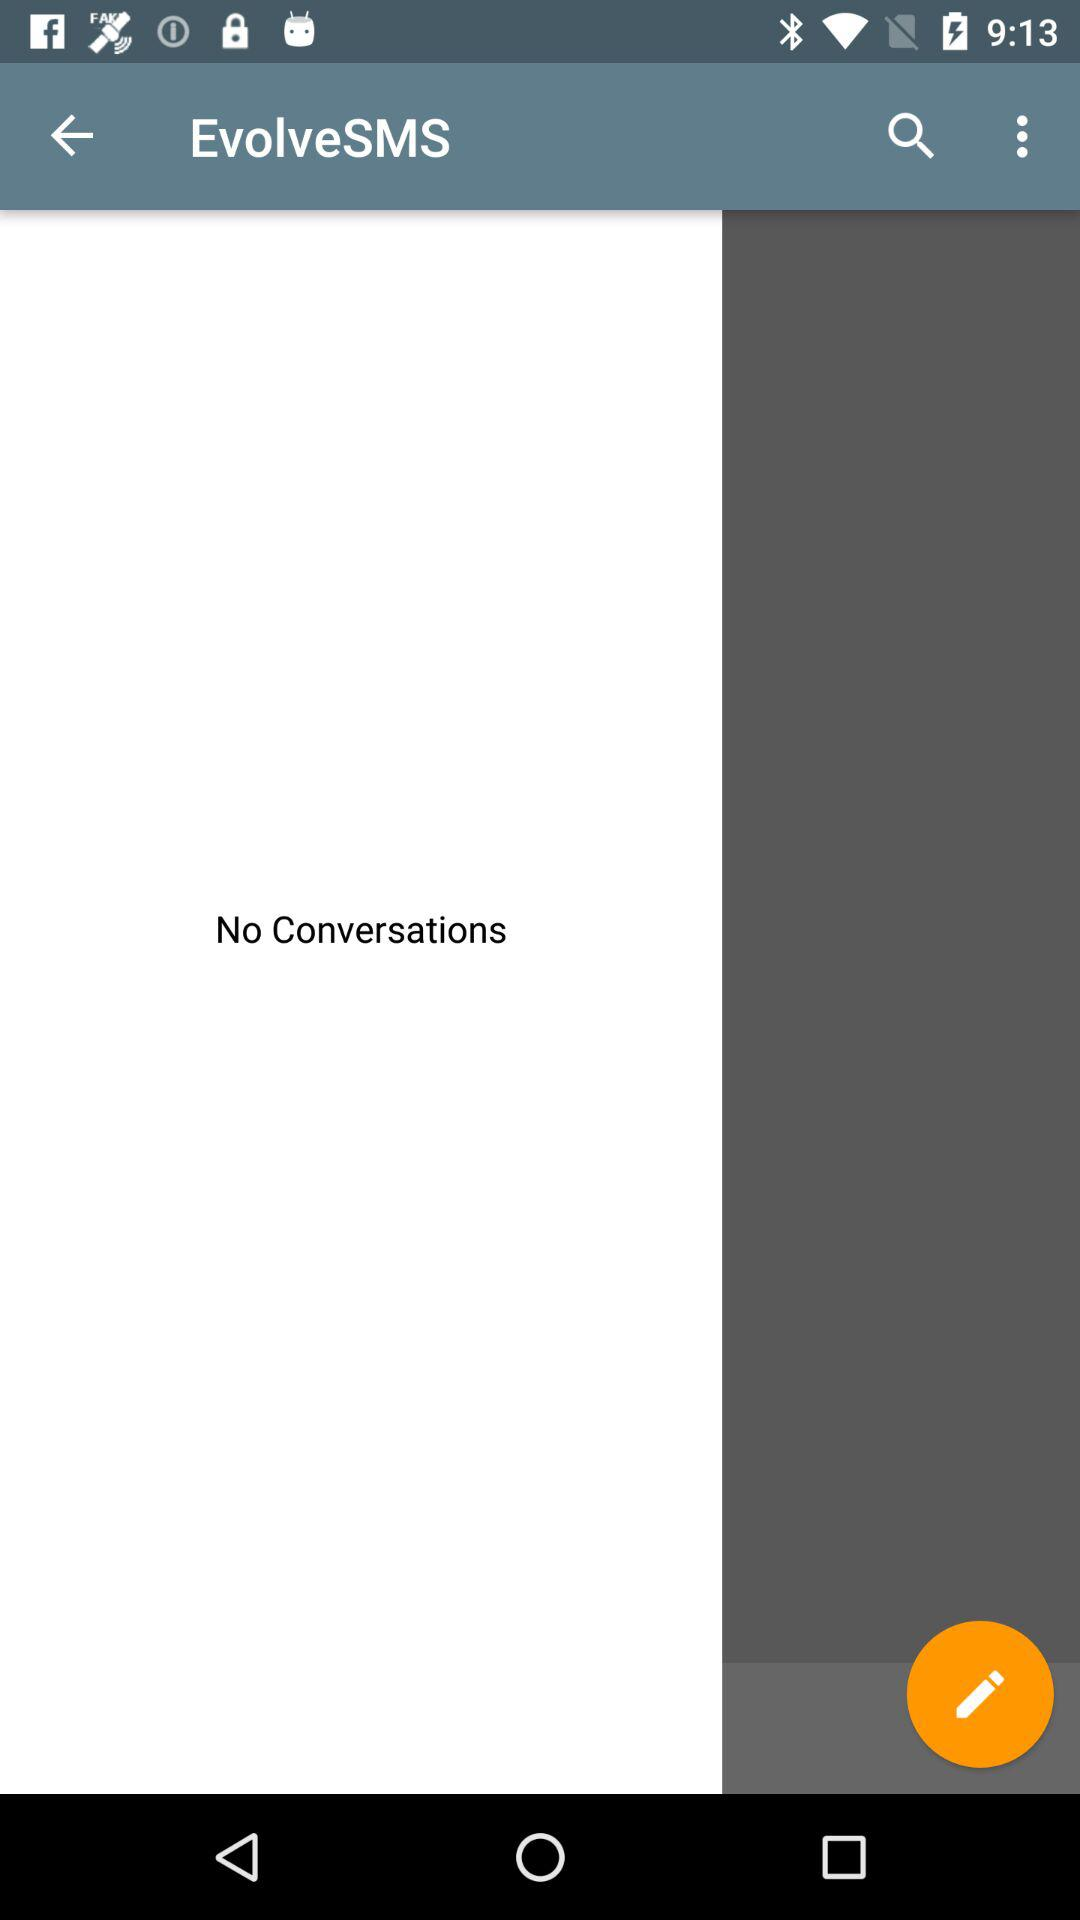What is the name of the application? The name of the application is "EvolveSMS". 